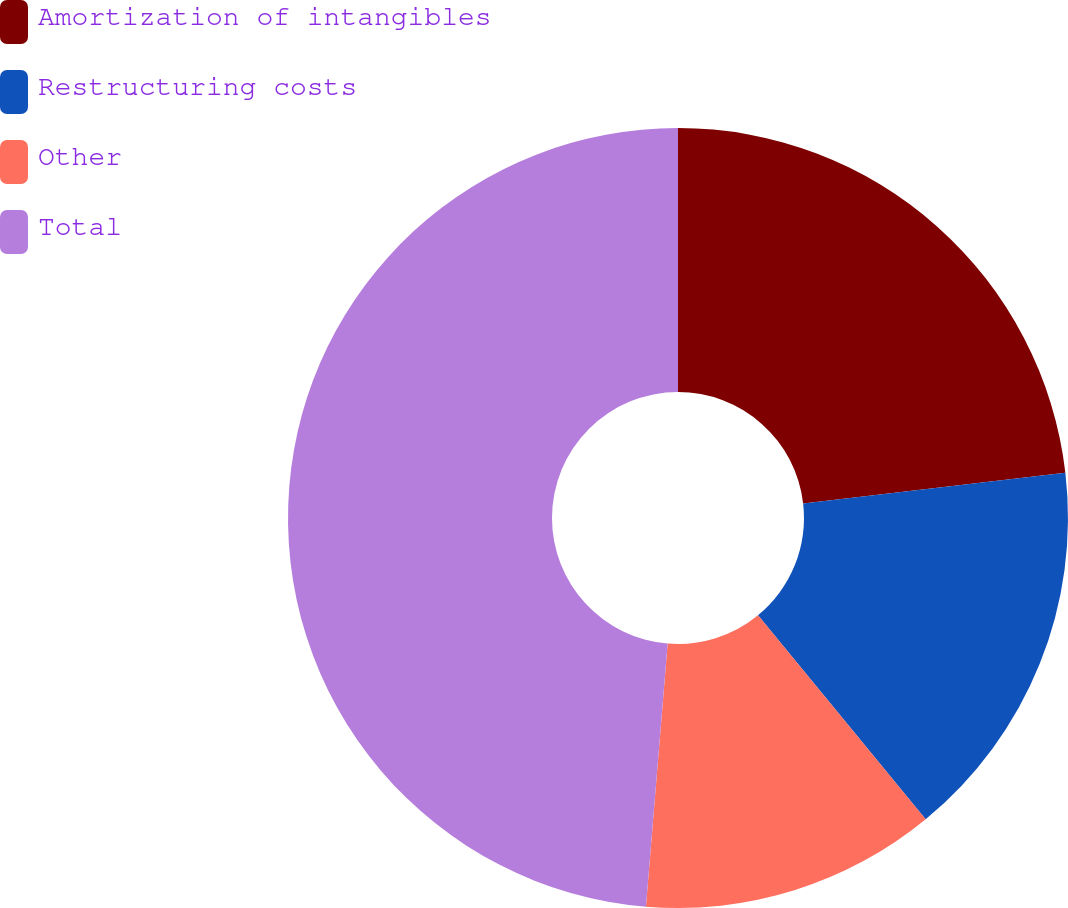Convert chart to OTSL. <chart><loc_0><loc_0><loc_500><loc_500><pie_chart><fcel>Amortization of intangibles<fcel>Restructuring costs<fcel>Other<fcel>Total<nl><fcel>23.15%<fcel>15.9%<fcel>12.26%<fcel>48.69%<nl></chart> 